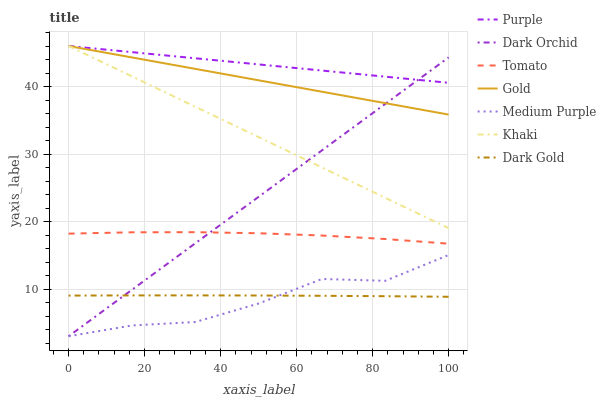Does Medium Purple have the minimum area under the curve?
Answer yes or no. Yes. Does Purple have the maximum area under the curve?
Answer yes or no. Yes. Does Khaki have the minimum area under the curve?
Answer yes or no. No. Does Khaki have the maximum area under the curve?
Answer yes or no. No. Is Khaki the smoothest?
Answer yes or no. Yes. Is Medium Purple the roughest?
Answer yes or no. Yes. Is Gold the smoothest?
Answer yes or no. No. Is Gold the roughest?
Answer yes or no. No. Does Dark Orchid have the lowest value?
Answer yes or no. Yes. Does Khaki have the lowest value?
Answer yes or no. No. Does Purple have the highest value?
Answer yes or no. Yes. Does Dark Gold have the highest value?
Answer yes or no. No. Is Dark Gold less than Khaki?
Answer yes or no. Yes. Is Purple greater than Tomato?
Answer yes or no. Yes. Does Dark Orchid intersect Tomato?
Answer yes or no. Yes. Is Dark Orchid less than Tomato?
Answer yes or no. No. Is Dark Orchid greater than Tomato?
Answer yes or no. No. Does Dark Gold intersect Khaki?
Answer yes or no. No. 